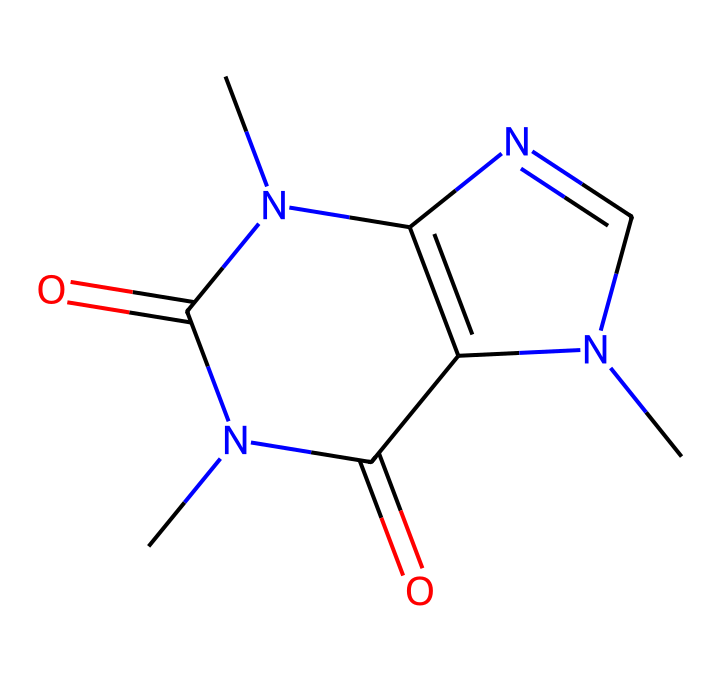What is the molecular formula of caffeine? To determine the molecular formula, we can break down the SMILES representation. The structure indicates the presence of carbon (C), hydrogen (H), nitrogen (N), and oxygen (O) atoms. Counting the elements yields: 8 carbons, 10 hydrogens, 4 nitrogens, and 2 oxygens, leading to the molecular formula C8H10N4O2.
Answer: C8H10N4O2 How many nitrogen atoms are present in caffeine? From the SMILES representation, we can identify the nitrogen atoms represented by 'N'. Count the occurrences of 'N', which shows there are 4 nitrogen atoms in total in the structure.
Answer: 4 What type of compound is caffeine classified as? Caffeine has a complex structure including nitrogen atoms and characteristics typical of alkaloids. Alkaloids often contain heterocyclic compounds where nitrogen atoms are part of the ring structure, which is indicative of caffeine’s classification as an alkaloid.
Answer: alkaloid What functional groups are present in caffeine? By analyzing the structure, we can see carbonyl (C=O) functional groups as indicated by the presence of double-bonded oxygen atoms. Additionally, the nitrogen atoms imply the presence of amine groups. Thus, caffeine contains carbonyl and amine functional groups.
Answer: carbonyl and amine How many rings are present in the caffeine structure? The SMILES indicates two joined cycles in the structure, as caffeine features multiple nitrogen atoms within its cyclic arrangement. Count the distinct ring structures reveals that there are two rings in total.
Answer: 2 What is the significance of caffeine's methyl groups? The structure shows that methyl groups (-CH3) are attached to the nitrogen atoms, which is significant because these groups contribute to caffeine's pharmacological effects, enhancing its stimulant properties.
Answer: stimulant properties 